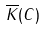<formula> <loc_0><loc_0><loc_500><loc_500>\overline { K } ( C )</formula> 